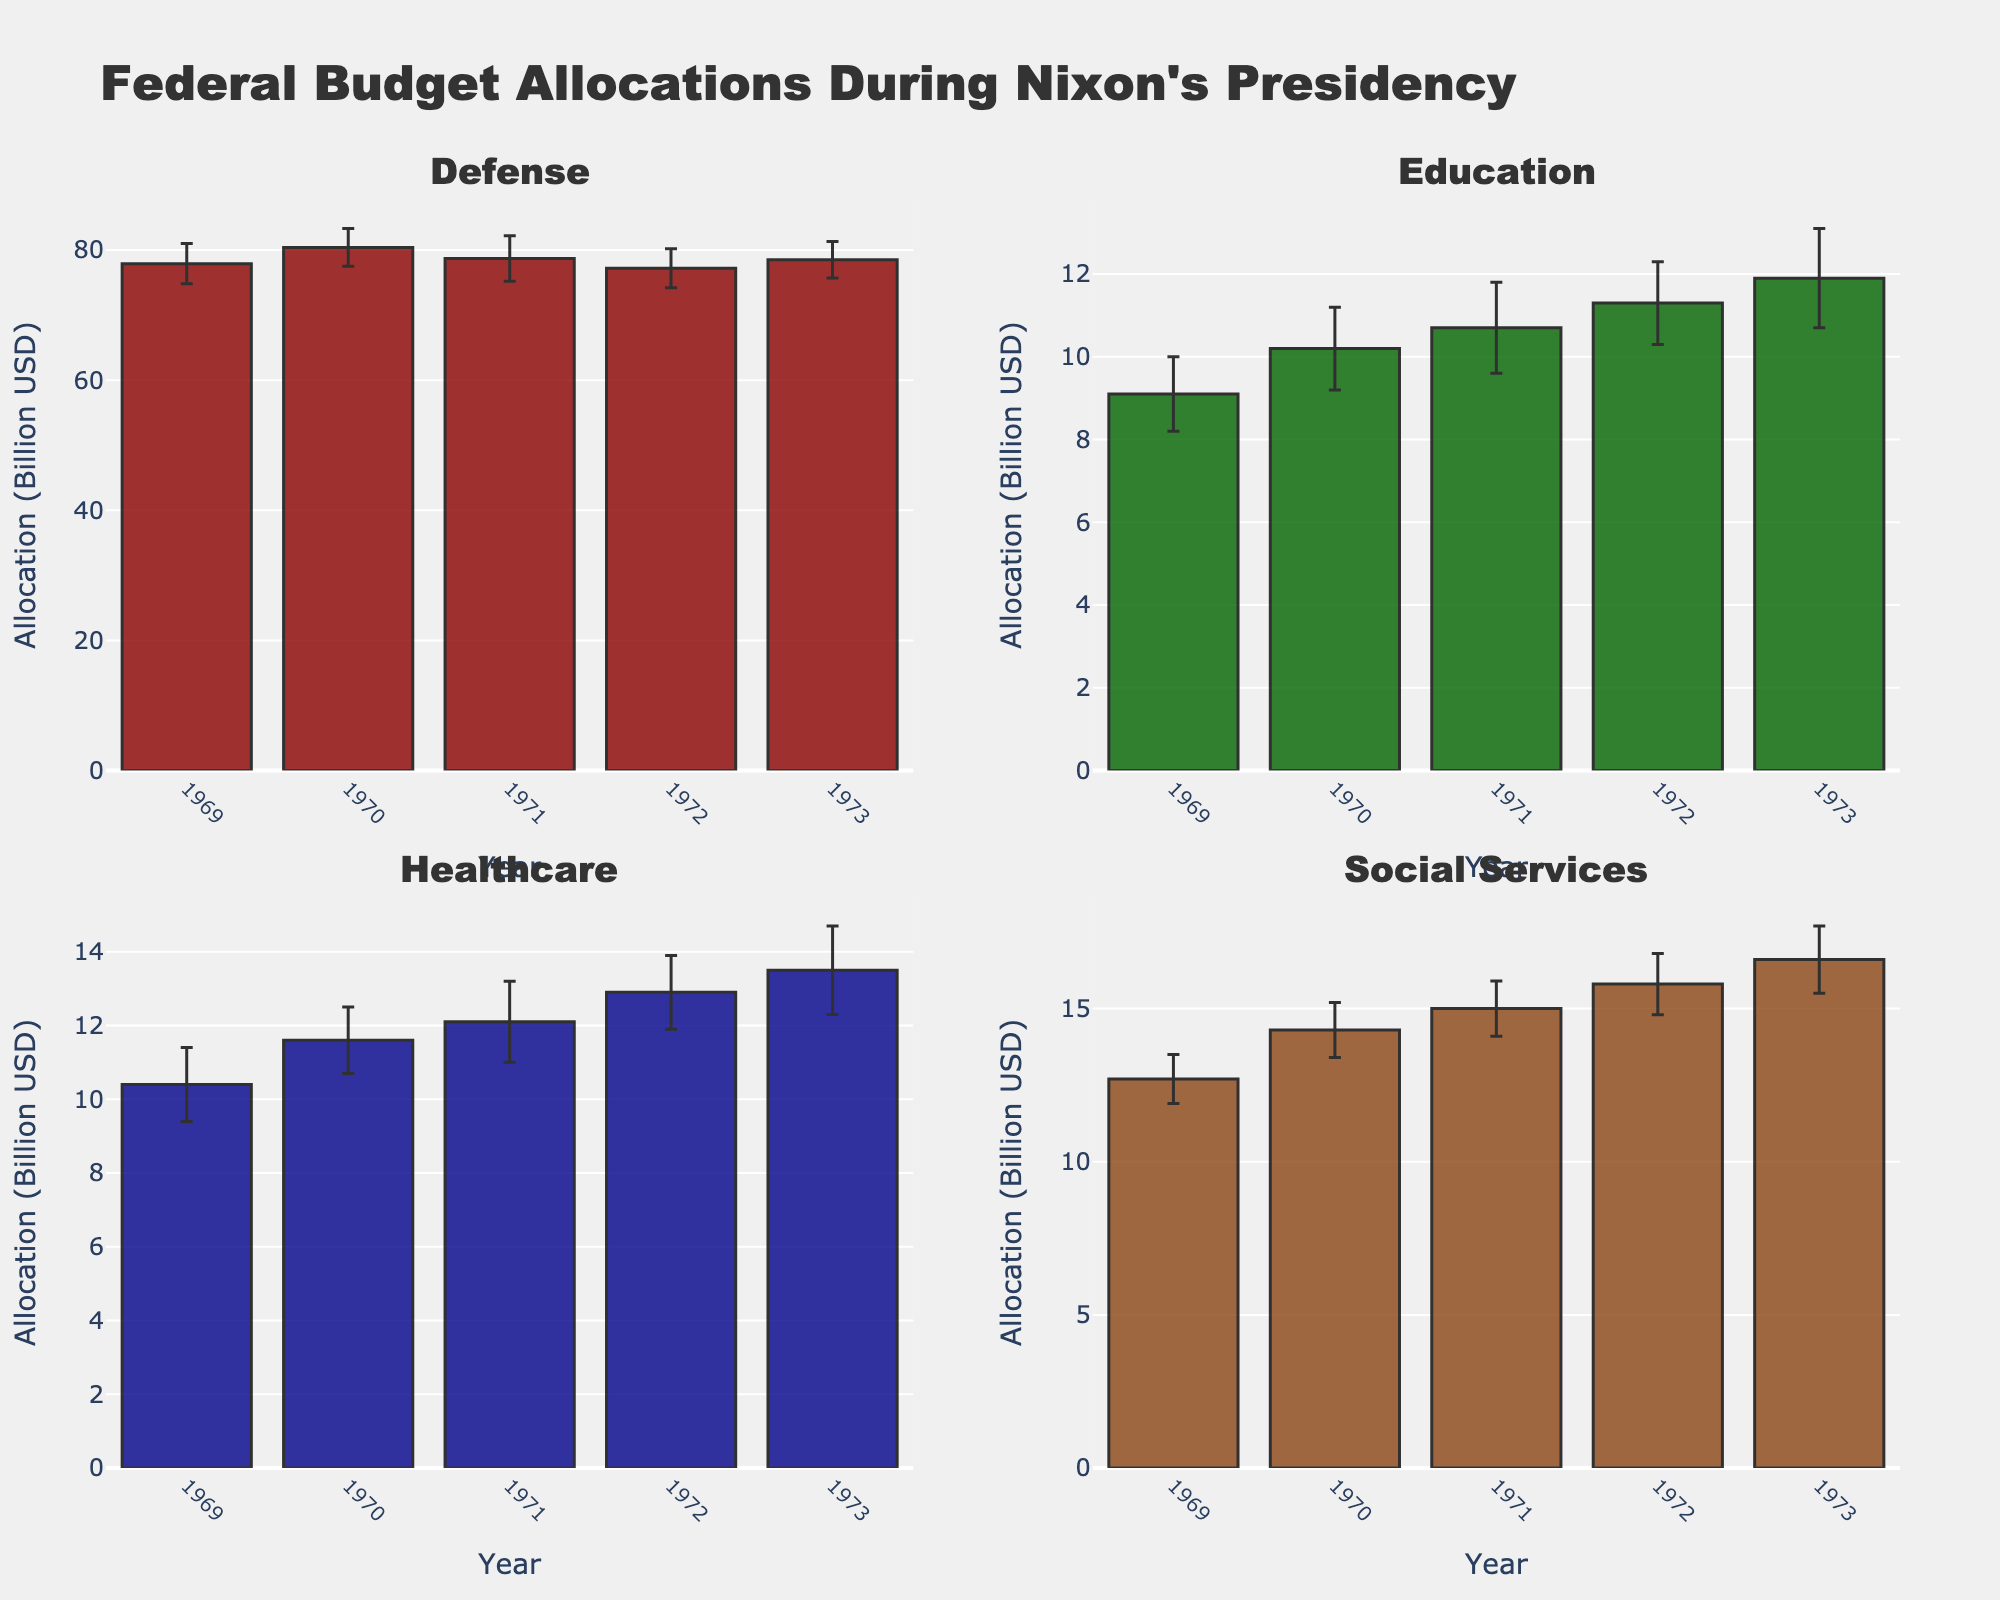What's the title of the chart? The title is prominently displayed at the top of the chart and reads "Federal Budget Allocations During Nixon's Presidency."
Answer: Federal Budget Allocations During Nixon's Presidency How many sectors are represented in the figure? The figure uses subplots marked with titles, each corresponding to a sector. There are four subplots.
Answer: 4 What's the average allocation for the Education sector in 1970 and 1973? To find the average, sum the allocations of Education in 1970 and 1973, then divide by 2: (10.2 + 11.9) / 2 = 11.05.
Answer: 11.05 Which sector received the highest allocation in 1969? By comparing the bar lengths for all sectors in 1969, the Defense sector shows the highest allocation of 77.9 billion USD.
Answer: Defense What was the general trend in the Healthcare sector's allocations from 1969 to 1973? Observing the heights of the bars in the Healthcare subplot, the allocations increased every year sequentially from 10.4 billion USD in 1969 to 13.5 billion USD in 1973.
Answer: Increasing Which year saw the largest funding allocation for Social Services? By comparing the bar heights in the Social Services subplot, the largest allocation is in 1973, with 16.6 billion USD.
Answer: 1973 How do the error margins for the Defense sector in 1969 and 1973 compare? By examining the error bars in the Defense subplot, the error margin in 1969 (3.1 billion USD) is slightly larger than in 1973 (2.8 billion USD).
Answer: Larger in 1969 Which sector experienced the smallest change in allocation between any two consecutive years? Looking for minimal differences in bar heights across years for each sector, Defense shows the smallest change from 1972 to 1973 (77.2 to 78.5).
Answer: Defense (1972 to 1973) What's the total allocation for the Healthcare sector over all five years? Sum the allocations from 1969 to 1973 for Healthcare: 10.4 + 11.6 + 12.1 + 12.9 + 13.5 = 60.5 billion USD.
Answer: 60.5 Between 1969 and 1970, which sector had the highest growth in allocation? The difference in allocations between 1969 and 1970 for all sectors is calculated; Social Services grew from 12.7 to 14.3, a 1.6 billion USD increase, the highest among all.
Answer: Social Services 